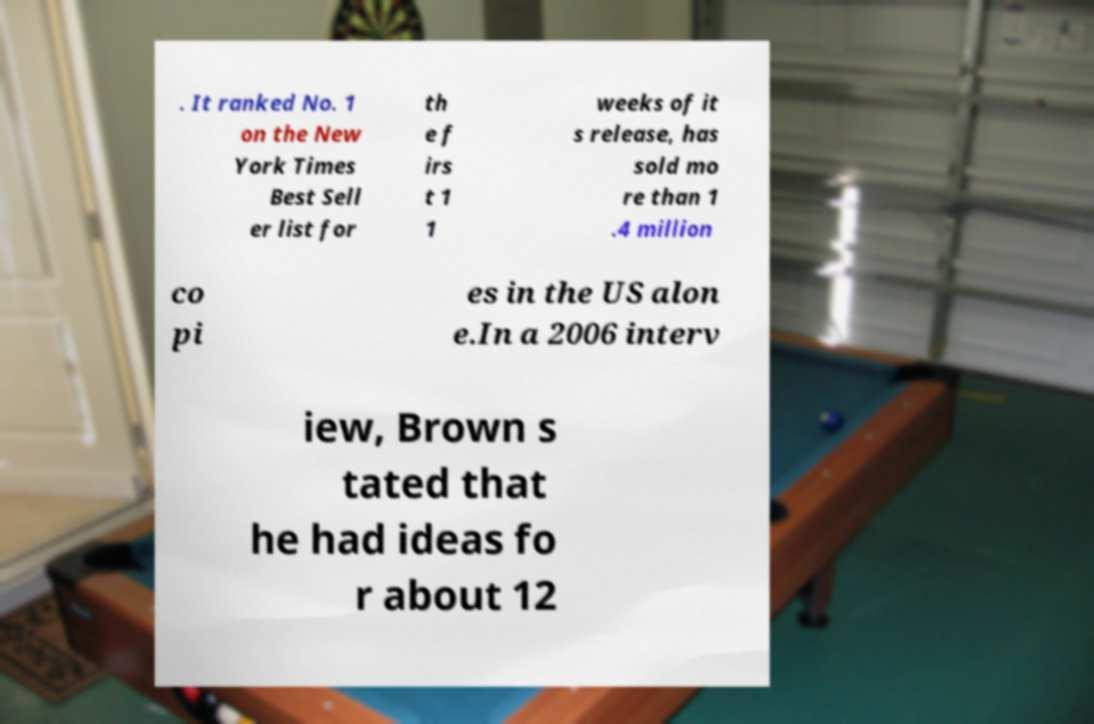Can you accurately transcribe the text from the provided image for me? . It ranked No. 1 on the New York Times Best Sell er list for th e f irs t 1 1 weeks of it s release, has sold mo re than 1 .4 million co pi es in the US alon e.In a 2006 interv iew, Brown s tated that he had ideas fo r about 12 